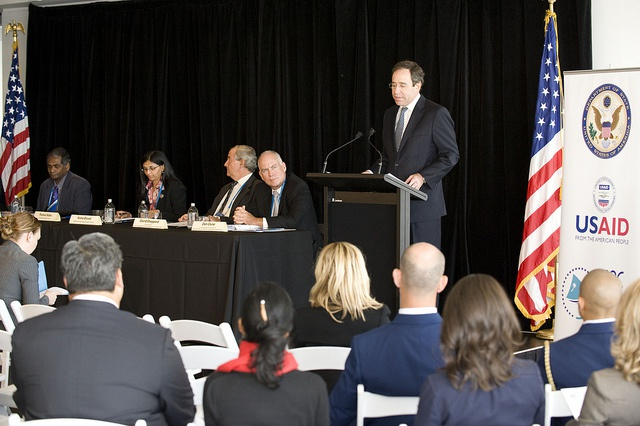Describe the objects in this image and their specific colors. I can see people in gray, black, darkgray, and white tones, people in gray, black, and maroon tones, people in gray, black, salmon, and maroon tones, people in gray, navy, darkblue, black, and lightgray tones, and people in gray, black, and lightgray tones in this image. 